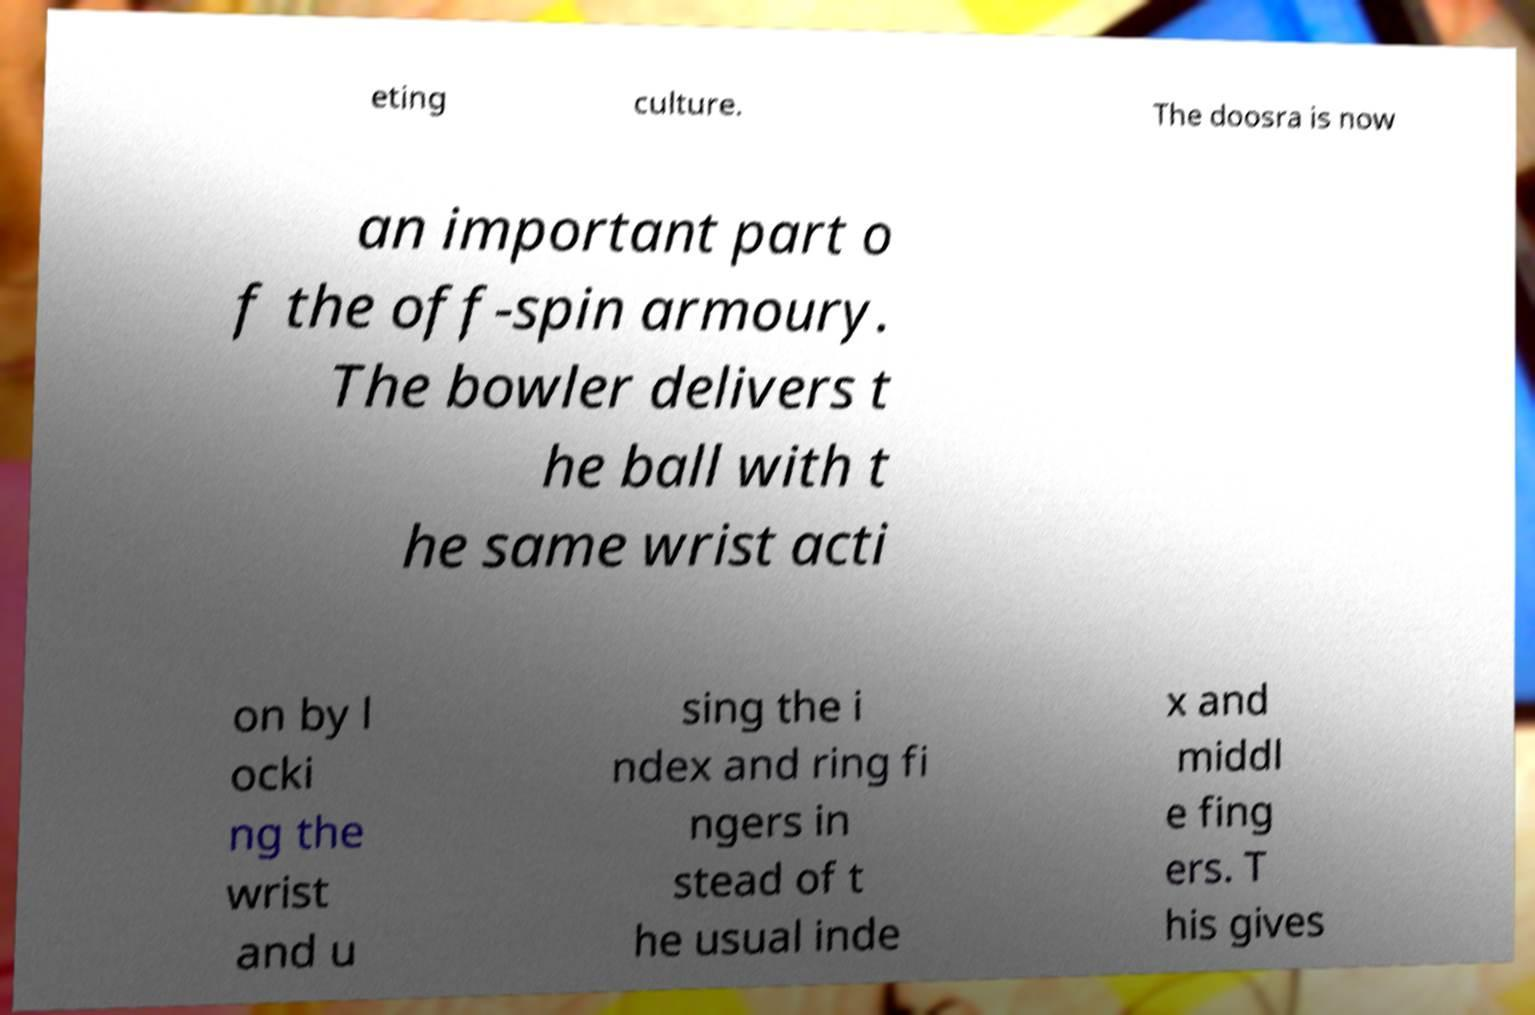For documentation purposes, I need the text within this image transcribed. Could you provide that? eting culture. The doosra is now an important part o f the off-spin armoury. The bowler delivers t he ball with t he same wrist acti on by l ocki ng the wrist and u sing the i ndex and ring fi ngers in stead of t he usual inde x and middl e fing ers. T his gives 